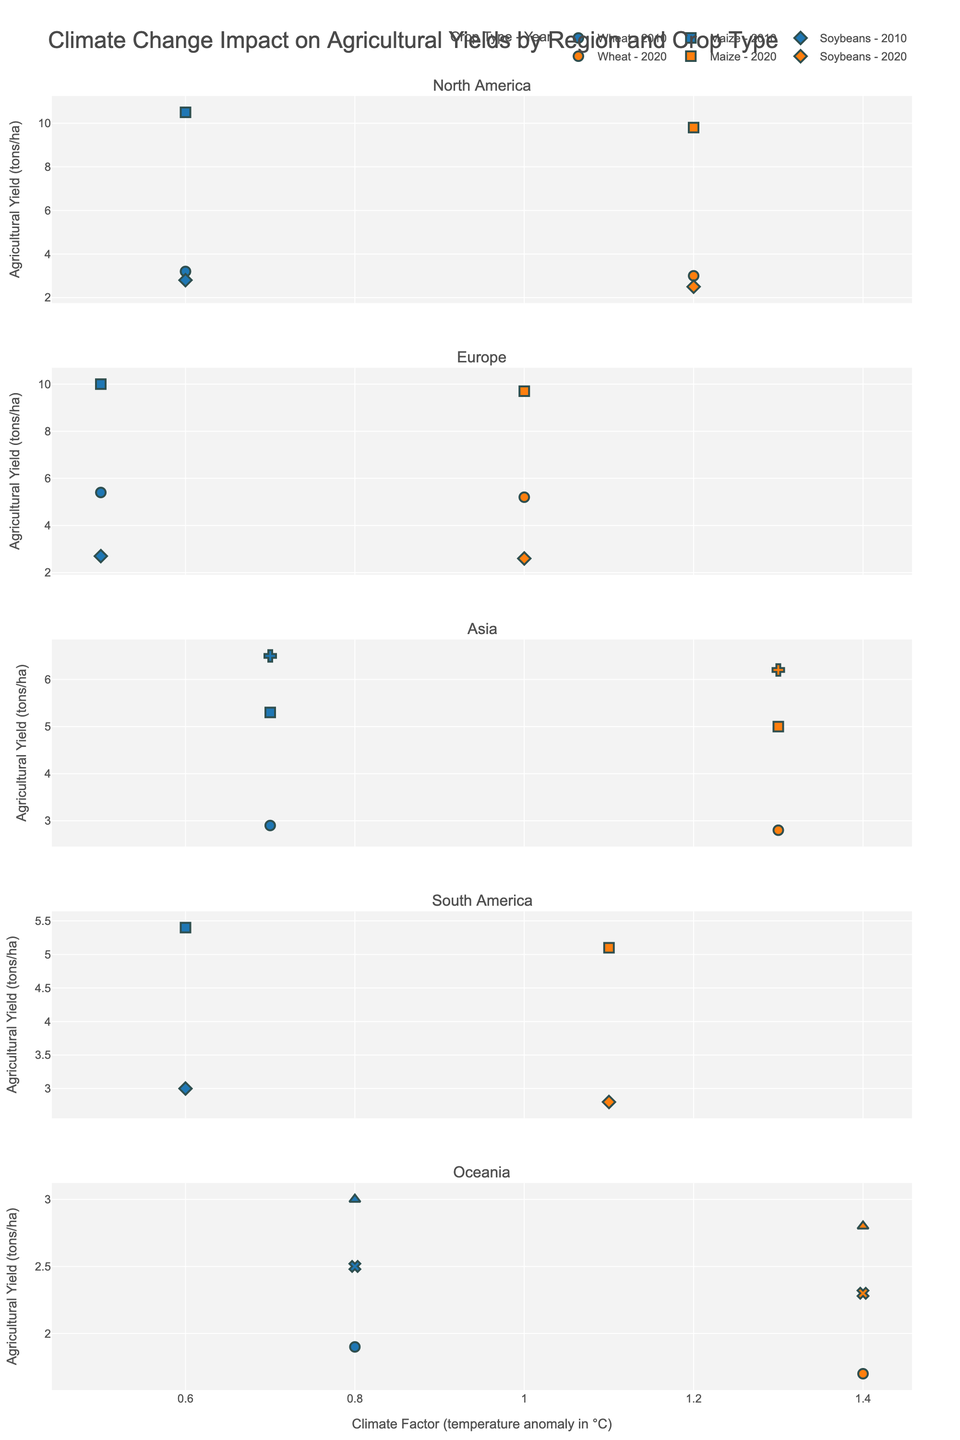What is the title of the plot? The title is typically found at the top of the plot. In this case, it should describe the content of the plot, which is the impact of climate change on agricultural yields by region and crop type.
Answer: Climate Change Impact on Agricultural Yields by Region and Crop Type What crops are represented in the European region? To find this, locate the subplot labeled "Europe" and identify the different crop types mentioned in the legend associated with the European scatter plot.
Answer: Wheat, Maize, Soybeans How many years are compared in each region? To determine this, check the legend or the data points in each subplot. The color coding and labels will indicate the years being compared.
Answer: 2 years Compare the average yield of Maize in North America between 2010 and 2020. Locate the data points for Maize in North America for both years. The average yield can be calculated by averaging the yields for the two years.
Answer: 10.15 tons/ha Which region experienced the largest decrease in Soybeans yield from 2010 to 2020? Check the subplots for Soybeans yield in all regions and compare the differences between 2010 and 2020. The largest drop will be identified by the biggest downward shift in the y-values.
Answer: North America What is the relationship between temperature anomaly and agricultural yield for Wheat in Oceania? Find the Wheat data points in the Oceania subplot. Compare the climate factor (x-axis) with the yield (y-axis) for both years. The relationship can be inferred by observing the trend between these two variables.
Answer: Negative correlation Which crop in Asia showed a notable decline in yield from 2010 to 2020? Compare the yield data points for each crop in the Asian subplot for the years 2010 and 2020. The crop with the most noticeable decline in y-values is the answer.
Answer: Rice What was the change in annual precipitation in Europe for Wheat from 2010 to 2020? Look at the hover information for Wheat in the European subplot. Note the annual precipitation for 2010 and 2020, then subtract the former from the latter to find the change.
Answer: -30 mm How does the agricultural yield of Sorghum in Oceania in 2020 compare to that in 2010? Look at the scattering points for Sorghum in the Oceania subplot and compare the y-values for the years 2010 and 2020 to see which year had higher yield.
Answer: Lower in 2020 What trend do you observe in the temperature anomaly over time across all regions? Examine the x-axis values across all subplots for both years. The overall change in x-values will illustrate the trend of temperature anomaly over time.
Answer: Increasing 